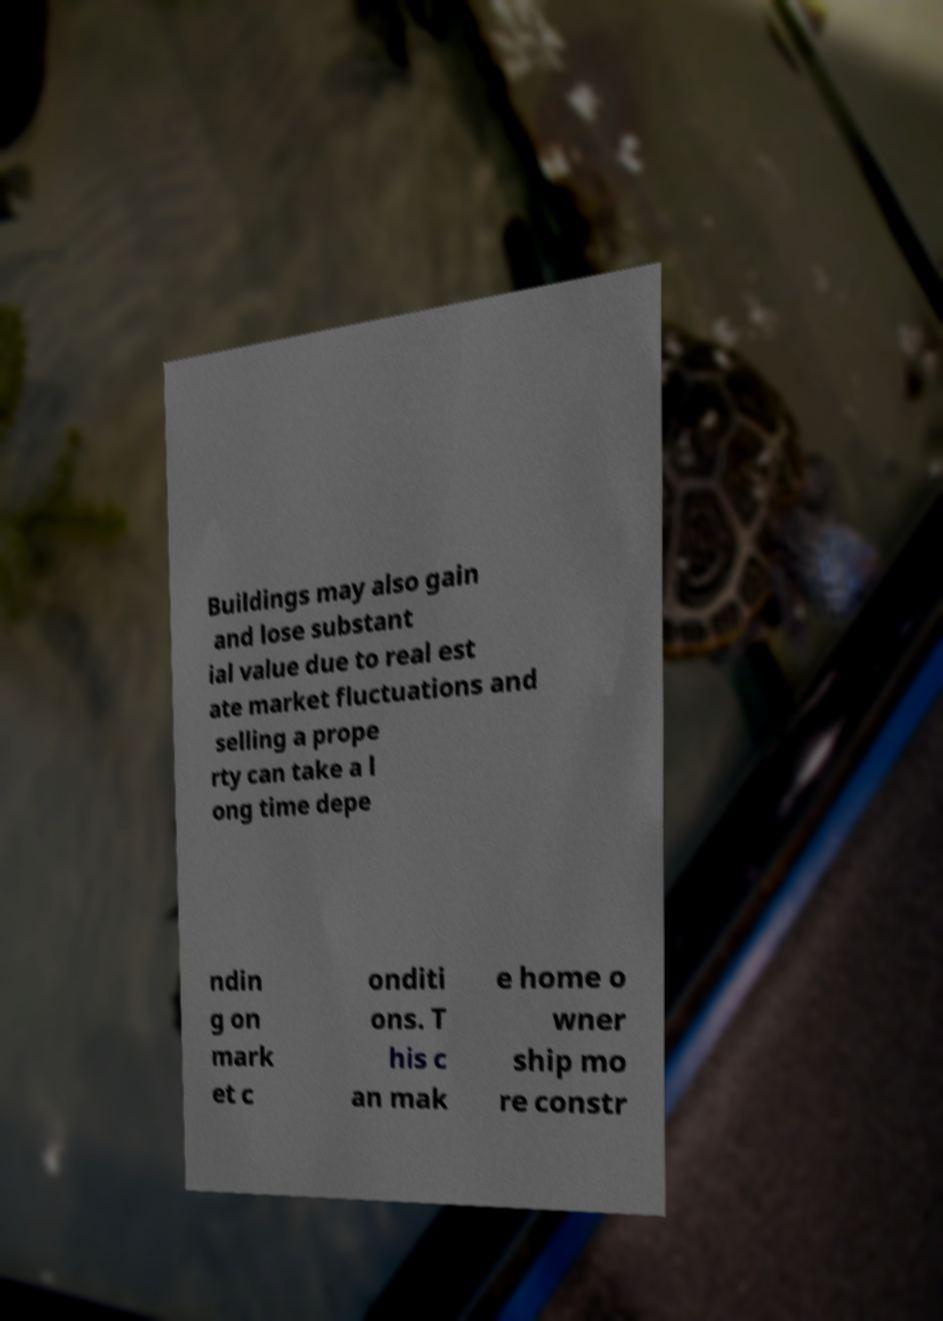Can you accurately transcribe the text from the provided image for me? Buildings may also gain and lose substant ial value due to real est ate market fluctuations and selling a prope rty can take a l ong time depe ndin g on mark et c onditi ons. T his c an mak e home o wner ship mo re constr 